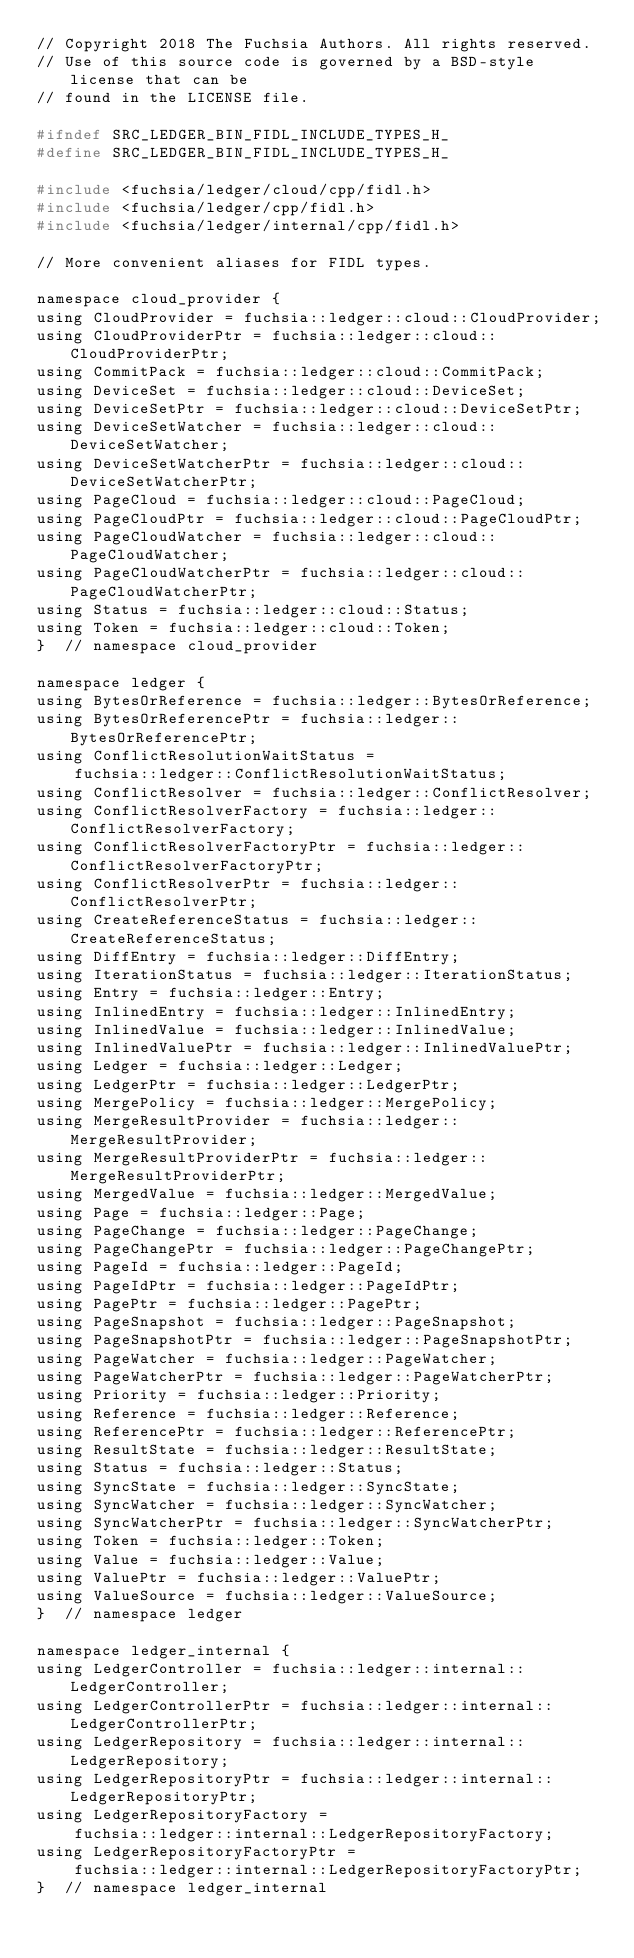Convert code to text. <code><loc_0><loc_0><loc_500><loc_500><_C_>// Copyright 2018 The Fuchsia Authors. All rights reserved.
// Use of this source code is governed by a BSD-style license that can be
// found in the LICENSE file.

#ifndef SRC_LEDGER_BIN_FIDL_INCLUDE_TYPES_H_
#define SRC_LEDGER_BIN_FIDL_INCLUDE_TYPES_H_

#include <fuchsia/ledger/cloud/cpp/fidl.h>
#include <fuchsia/ledger/cpp/fidl.h>
#include <fuchsia/ledger/internal/cpp/fidl.h>

// More convenient aliases for FIDL types.

namespace cloud_provider {
using CloudProvider = fuchsia::ledger::cloud::CloudProvider;
using CloudProviderPtr = fuchsia::ledger::cloud::CloudProviderPtr;
using CommitPack = fuchsia::ledger::cloud::CommitPack;
using DeviceSet = fuchsia::ledger::cloud::DeviceSet;
using DeviceSetPtr = fuchsia::ledger::cloud::DeviceSetPtr;
using DeviceSetWatcher = fuchsia::ledger::cloud::DeviceSetWatcher;
using DeviceSetWatcherPtr = fuchsia::ledger::cloud::DeviceSetWatcherPtr;
using PageCloud = fuchsia::ledger::cloud::PageCloud;
using PageCloudPtr = fuchsia::ledger::cloud::PageCloudPtr;
using PageCloudWatcher = fuchsia::ledger::cloud::PageCloudWatcher;
using PageCloudWatcherPtr = fuchsia::ledger::cloud::PageCloudWatcherPtr;
using Status = fuchsia::ledger::cloud::Status;
using Token = fuchsia::ledger::cloud::Token;
}  // namespace cloud_provider

namespace ledger {
using BytesOrReference = fuchsia::ledger::BytesOrReference;
using BytesOrReferencePtr = fuchsia::ledger::BytesOrReferencePtr;
using ConflictResolutionWaitStatus =
    fuchsia::ledger::ConflictResolutionWaitStatus;
using ConflictResolver = fuchsia::ledger::ConflictResolver;
using ConflictResolverFactory = fuchsia::ledger::ConflictResolverFactory;
using ConflictResolverFactoryPtr = fuchsia::ledger::ConflictResolverFactoryPtr;
using ConflictResolverPtr = fuchsia::ledger::ConflictResolverPtr;
using CreateReferenceStatus = fuchsia::ledger::CreateReferenceStatus;
using DiffEntry = fuchsia::ledger::DiffEntry;
using IterationStatus = fuchsia::ledger::IterationStatus;
using Entry = fuchsia::ledger::Entry;
using InlinedEntry = fuchsia::ledger::InlinedEntry;
using InlinedValue = fuchsia::ledger::InlinedValue;
using InlinedValuePtr = fuchsia::ledger::InlinedValuePtr;
using Ledger = fuchsia::ledger::Ledger;
using LedgerPtr = fuchsia::ledger::LedgerPtr;
using MergePolicy = fuchsia::ledger::MergePolicy;
using MergeResultProvider = fuchsia::ledger::MergeResultProvider;
using MergeResultProviderPtr = fuchsia::ledger::MergeResultProviderPtr;
using MergedValue = fuchsia::ledger::MergedValue;
using Page = fuchsia::ledger::Page;
using PageChange = fuchsia::ledger::PageChange;
using PageChangePtr = fuchsia::ledger::PageChangePtr;
using PageId = fuchsia::ledger::PageId;
using PageIdPtr = fuchsia::ledger::PageIdPtr;
using PagePtr = fuchsia::ledger::PagePtr;
using PageSnapshot = fuchsia::ledger::PageSnapshot;
using PageSnapshotPtr = fuchsia::ledger::PageSnapshotPtr;
using PageWatcher = fuchsia::ledger::PageWatcher;
using PageWatcherPtr = fuchsia::ledger::PageWatcherPtr;
using Priority = fuchsia::ledger::Priority;
using Reference = fuchsia::ledger::Reference;
using ReferencePtr = fuchsia::ledger::ReferencePtr;
using ResultState = fuchsia::ledger::ResultState;
using Status = fuchsia::ledger::Status;
using SyncState = fuchsia::ledger::SyncState;
using SyncWatcher = fuchsia::ledger::SyncWatcher;
using SyncWatcherPtr = fuchsia::ledger::SyncWatcherPtr;
using Token = fuchsia::ledger::Token;
using Value = fuchsia::ledger::Value;
using ValuePtr = fuchsia::ledger::ValuePtr;
using ValueSource = fuchsia::ledger::ValueSource;
}  // namespace ledger

namespace ledger_internal {
using LedgerController = fuchsia::ledger::internal::LedgerController;
using LedgerControllerPtr = fuchsia::ledger::internal::LedgerControllerPtr;
using LedgerRepository = fuchsia::ledger::internal::LedgerRepository;
using LedgerRepositoryPtr = fuchsia::ledger::internal::LedgerRepositoryPtr;
using LedgerRepositoryFactory =
    fuchsia::ledger::internal::LedgerRepositoryFactory;
using LedgerRepositoryFactoryPtr =
    fuchsia::ledger::internal::LedgerRepositoryFactoryPtr;
}  // namespace ledger_internal
</code> 